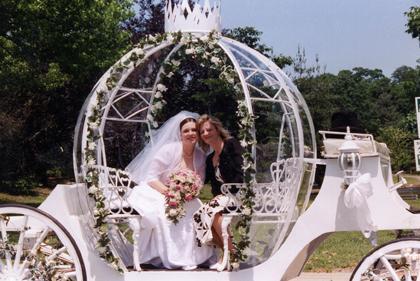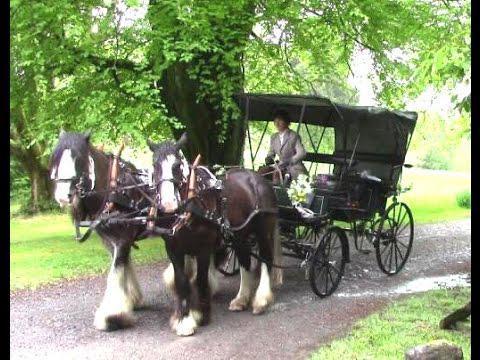The first image is the image on the left, the second image is the image on the right. Evaluate the accuracy of this statement regarding the images: "In both images, a bride is visible next to a horse and carriage.". Is it true? Answer yes or no. No. The first image is the image on the left, the second image is the image on the right. Examine the images to the left and right. Is the description "Nine or more mammals are visible." accurate? Answer yes or no. No. 